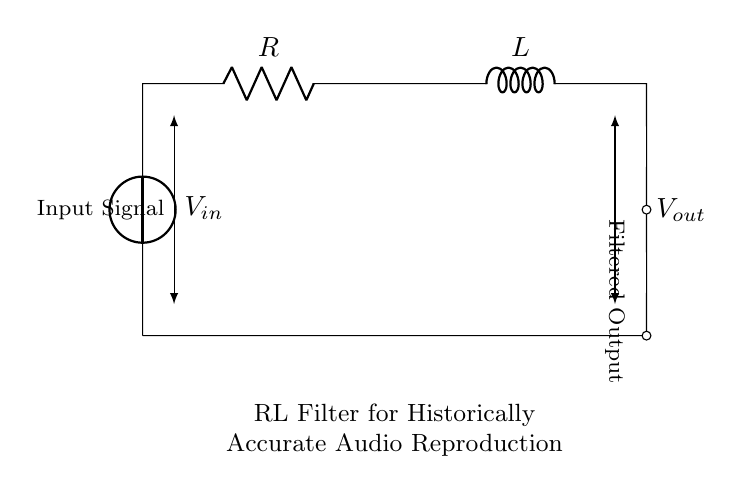What is the input voltage of this circuit? The input voltage is labeled as V in the diagram, indicating the source of the input signal.
Answer: V in What components are present in this circuit? There are two primary components visible in the circuit: a resistor and an inductor, specifically labeled as R and L.
Answer: Resistor and inductor What type of filter does this circuit represent? The circuit showcases a Resistor-Inductor filter, indicating it is designed to filter signals, particularly for audio applications.
Answer: RL filter How does this circuit affect audio signal quality? The Resistor-Inductor configuration allows certain frequencies to pass while attenuating others, thereby enhancing the quality of the reproduced audio by minimizing unwanted noise.
Answer: Enhances audio quality What is the output signal's relationship to the input? The output signal is derived from the input signal after passing through the RL filter, which modifies its amplitude and frequency characteristics.
Answer: Filtered output What is the intended purpose of this RL filter in audio equipment? The RL filter's purpose is to reproduce historically accurate sound recordings by selectively filtering frequencies to closely match the original audio quality.
Answer: Historical sound reproduction 